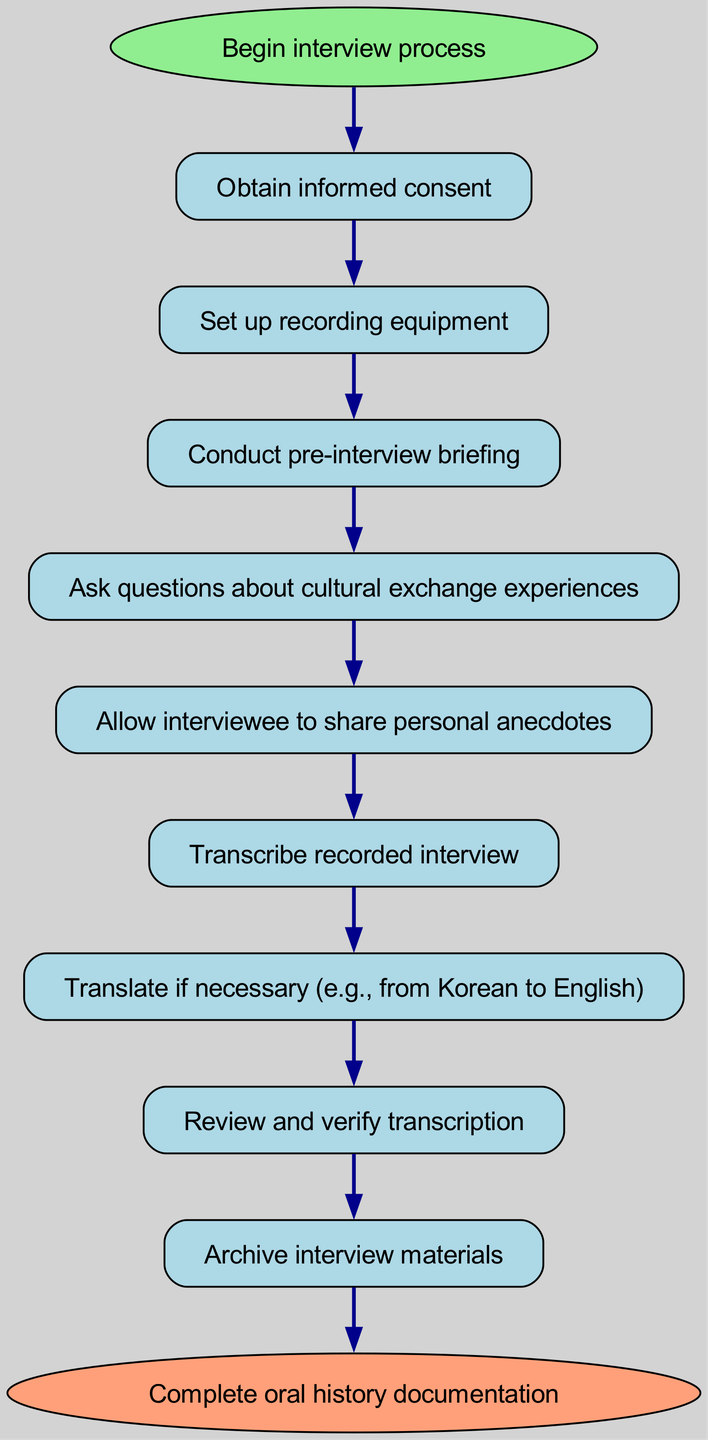What is the first step in the interview process? The first step is to "Obtain informed consent," which is represented as the first node accessible directly from the starting point of the diagram.
Answer: Obtain informed consent How many nodes are there in the diagram? The diagram includes a total of ten nodes: one start node, eight process nodes, and one end node, which includes all steps from beginning to completion.
Answer: Ten What follows after reviewing and verifying the transcription? After reviewing and verifying the transcription, the next step is to "Archive interview materials," which connects directly to the node referencing the transcription review.
Answer: Archive interview materials Which node is directly linked to the "Ask questions about cultural exchange experiences" node? The node directly linked to "Ask questions about cultural exchange experiences" is "Allow interviewee to share personal anecdotes," indicating the flow from one activity to the next.
Answer: Allow interviewee to share personal anecdotes How many edges connect the process nodes in total? There are nine edges connecting the process nodes, marking every transition from one step to the next, starting from "Begin interview process" to "Complete oral history documentation."
Answer: Nine What process follows conducting the pre-interview briefing? After conducting the pre-interview briefing, the next step is "Ask questions about cultural exchange experiences," which indicates the continuation of the interview process.
Answer: Ask questions about cultural exchange experiences What action occurs if translation is deemed necessary? If translation is necessary, the step "Translate if necessary (e.g., from Korean to English)" is invoked, which follows the transcription of the recorded interview.
Answer: Translate if necessary (e.g., from Korean to English) What is the final step in the flowchart? The final step in the flowchart is "Complete oral history documentation," which is reached once all prior steps have been thoroughly executed and documented.
Answer: Complete oral history documentation 